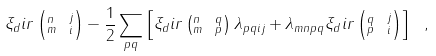<formula> <loc_0><loc_0><loc_500><loc_500>\xi _ { d } i r \left ( _ { m } ^ { n } \ _ { i } ^ { j } \right ) - \frac { 1 } { 2 } \sum _ { p q } \left [ \xi _ { d } i r \left ( _ { m } ^ { n } \ _ { p } ^ { q } \right ) \lambda _ { p q i j } + \lambda _ { m n p q } \xi _ { d } i r \left ( _ { p } ^ { q } \ _ { i } ^ { j } \right ) \right ] \ ,</formula> 